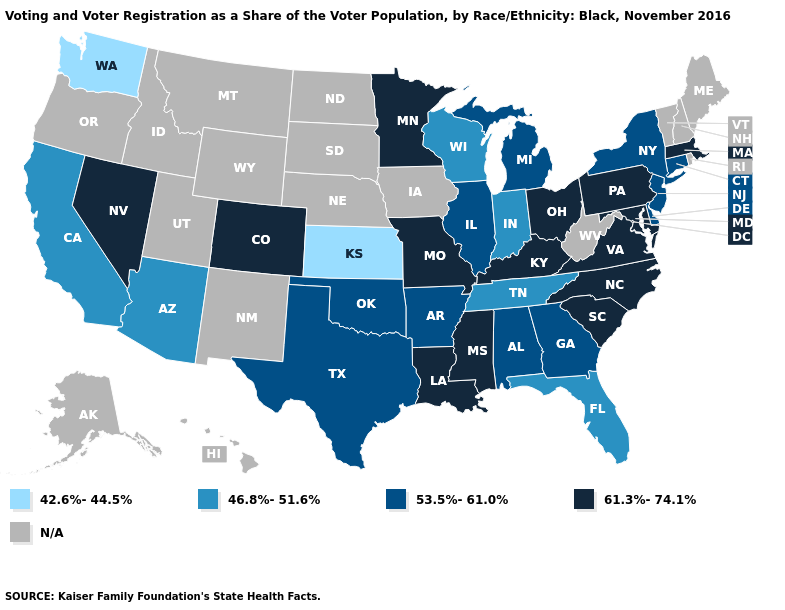Does the map have missing data?
Write a very short answer. Yes. Name the states that have a value in the range 53.5%-61.0%?
Short answer required. Alabama, Arkansas, Connecticut, Delaware, Georgia, Illinois, Michigan, New Jersey, New York, Oklahoma, Texas. Does Mississippi have the highest value in the USA?
Be succinct. Yes. Does Massachusetts have the lowest value in the Northeast?
Be succinct. No. What is the highest value in states that border Kansas?
Give a very brief answer. 61.3%-74.1%. What is the highest value in the USA?
Give a very brief answer. 61.3%-74.1%. What is the value of Hawaii?
Short answer required. N/A. Among the states that border Delaware , does Pennsylvania have the highest value?
Be succinct. Yes. Does Wisconsin have the lowest value in the USA?
Quick response, please. No. Name the states that have a value in the range 53.5%-61.0%?
Be succinct. Alabama, Arkansas, Connecticut, Delaware, Georgia, Illinois, Michigan, New Jersey, New York, Oklahoma, Texas. What is the value of Louisiana?
Give a very brief answer. 61.3%-74.1%. Does New York have the highest value in the Northeast?
Answer briefly. No. Which states have the lowest value in the South?
Give a very brief answer. Florida, Tennessee. 